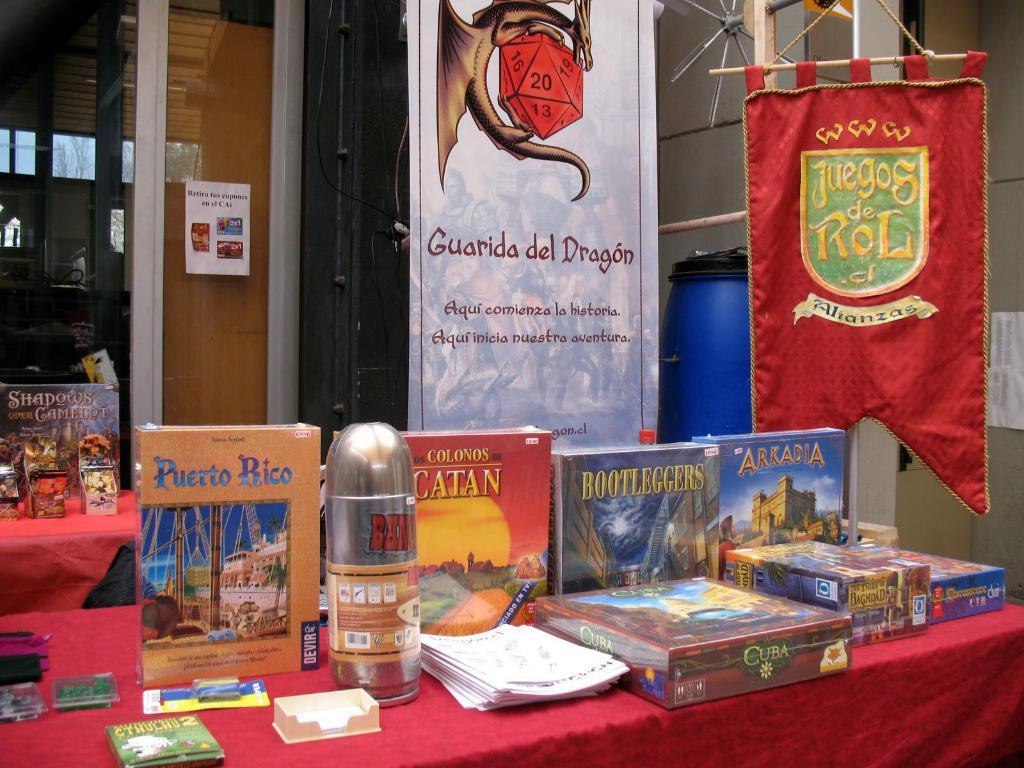<image>
Present a compact description of the photo's key features. One on the books on the table is titled Bootleggers. 